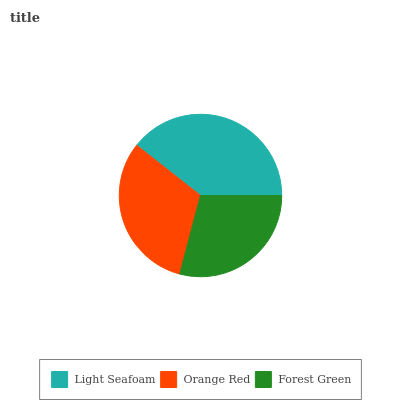Is Forest Green the minimum?
Answer yes or no. Yes. Is Light Seafoam the maximum?
Answer yes or no. Yes. Is Orange Red the minimum?
Answer yes or no. No. Is Orange Red the maximum?
Answer yes or no. No. Is Light Seafoam greater than Orange Red?
Answer yes or no. Yes. Is Orange Red less than Light Seafoam?
Answer yes or no. Yes. Is Orange Red greater than Light Seafoam?
Answer yes or no. No. Is Light Seafoam less than Orange Red?
Answer yes or no. No. Is Orange Red the high median?
Answer yes or no. Yes. Is Orange Red the low median?
Answer yes or no. Yes. Is Forest Green the high median?
Answer yes or no. No. Is Light Seafoam the low median?
Answer yes or no. No. 